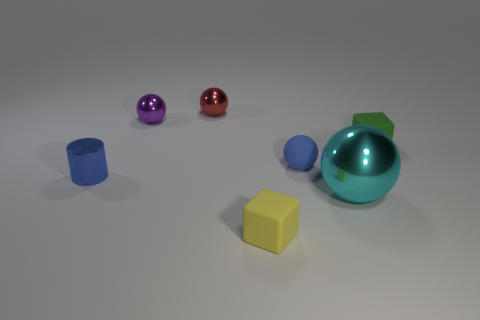Subtract 1 balls. How many balls are left? 3 Add 1 small rubber cubes. How many objects exist? 8 Subtract all blocks. How many objects are left? 5 Add 1 tiny gray shiny things. How many tiny gray shiny things exist? 1 Subtract 0 brown cubes. How many objects are left? 7 Subtract all small objects. Subtract all brown metal cylinders. How many objects are left? 1 Add 7 large metal objects. How many large metal objects are left? 8 